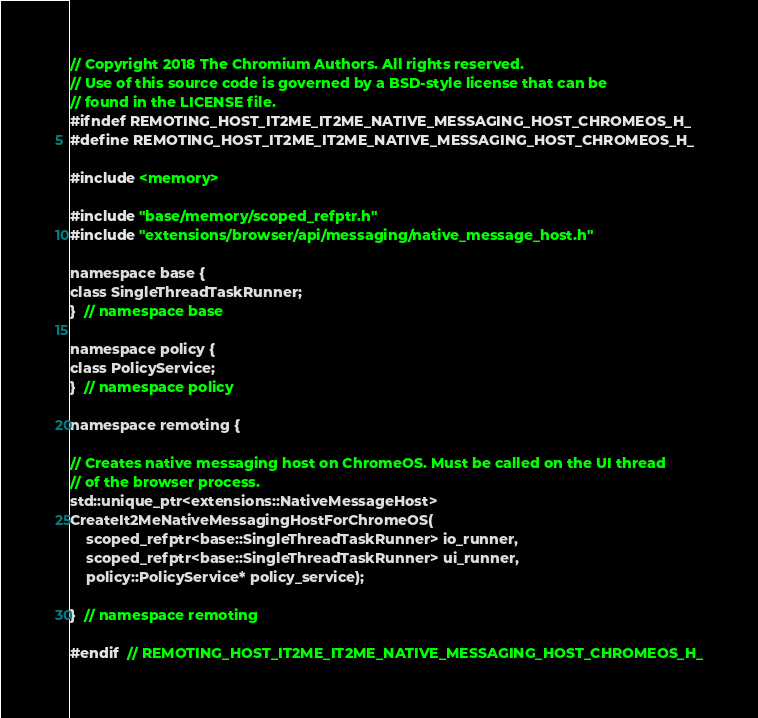Convert code to text. <code><loc_0><loc_0><loc_500><loc_500><_C_>// Copyright 2018 The Chromium Authors. All rights reserved.
// Use of this source code is governed by a BSD-style license that can be
// found in the LICENSE file.
#ifndef REMOTING_HOST_IT2ME_IT2ME_NATIVE_MESSAGING_HOST_CHROMEOS_H_
#define REMOTING_HOST_IT2ME_IT2ME_NATIVE_MESSAGING_HOST_CHROMEOS_H_

#include <memory>

#include "base/memory/scoped_refptr.h"
#include "extensions/browser/api/messaging/native_message_host.h"

namespace base {
class SingleThreadTaskRunner;
}  // namespace base

namespace policy {
class PolicyService;
}  // namespace policy

namespace remoting {

// Creates native messaging host on ChromeOS. Must be called on the UI thread
// of the browser process.
std::unique_ptr<extensions::NativeMessageHost>
CreateIt2MeNativeMessagingHostForChromeOS(
    scoped_refptr<base::SingleThreadTaskRunner> io_runner,
    scoped_refptr<base::SingleThreadTaskRunner> ui_runner,
    policy::PolicyService* policy_service);

}  // namespace remoting

#endif  // REMOTING_HOST_IT2ME_IT2ME_NATIVE_MESSAGING_HOST_CHROMEOS_H_
</code> 